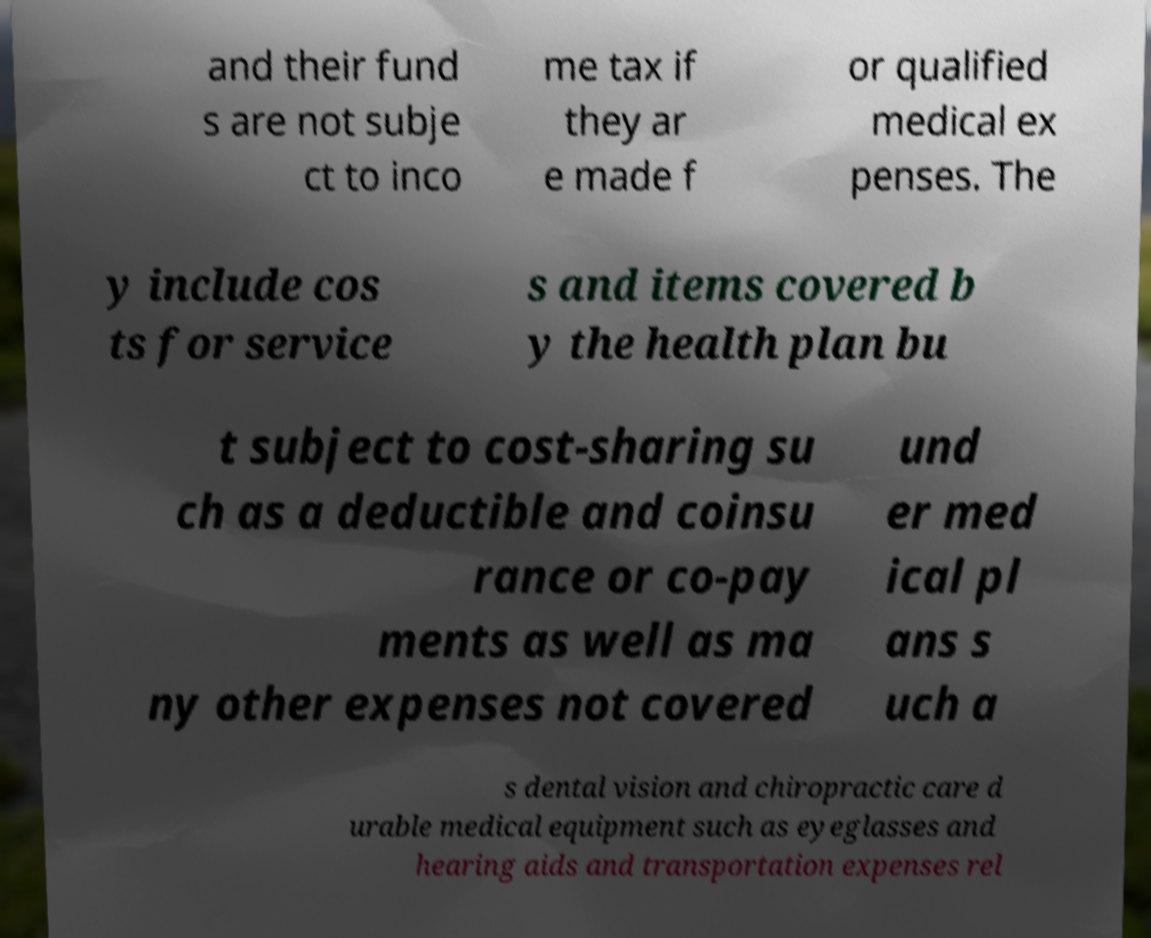Please identify and transcribe the text found in this image. and their fund s are not subje ct to inco me tax if they ar e made f or qualified medical ex penses. The y include cos ts for service s and items covered b y the health plan bu t subject to cost-sharing su ch as a deductible and coinsu rance or co-pay ments as well as ma ny other expenses not covered und er med ical pl ans s uch a s dental vision and chiropractic care d urable medical equipment such as eyeglasses and hearing aids and transportation expenses rel 